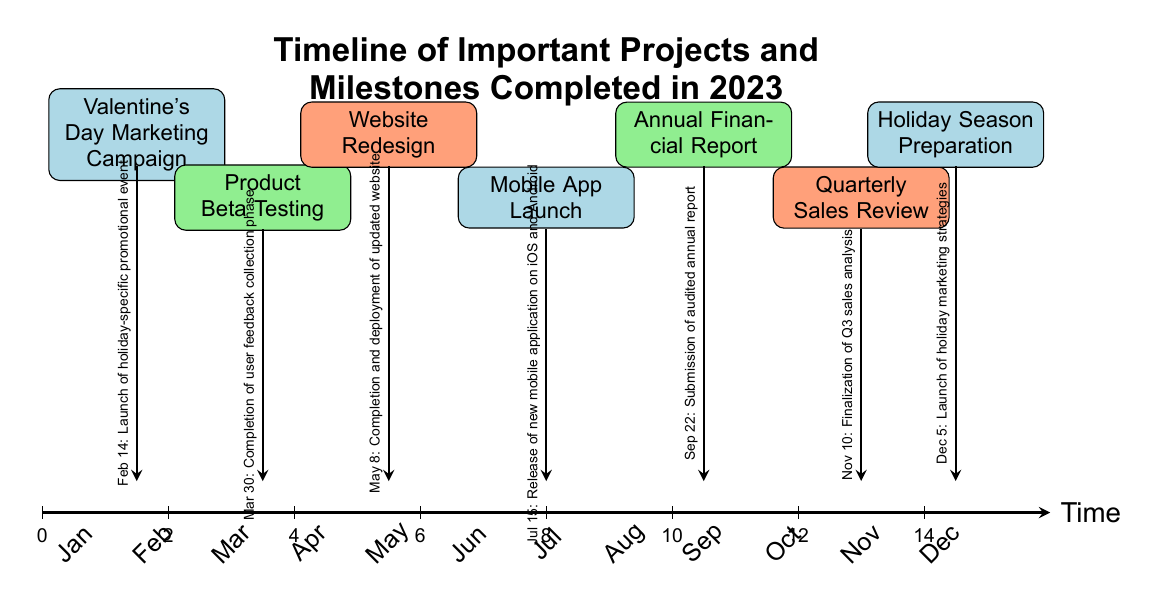What is the first project listed in the timeline? The first project listed in the timeline is the Valentine's Day Marketing Campaign, which is positioned at the coordinate (1.5, 6) on the diagram.
Answer: Valentine's Day Marketing Campaign How many projects were completed in the second quarter of 2023? The second quarter includes the months of April, May, and June. The only project completed in this timeframe is the Website Redesign in May. Thus, there is one project in Q2.
Answer: 1 What date is associated with the Mobile App Launch? The Mobile App Launch is associated with the date July 15, which is indicated next to the project node located at (8, 5) in the diagram.
Answer: July 15 Which project was completed just before the Annual Financial Report? The project completed just before the Annual Financial Report is the Mobile App Launch, as it occurs in July, while the Annual Financial Report is submitted in September.
Answer: Mobile App Launch How many months apart are the Valentine's Day Marketing Campaign and the Website Redesign? The Valentine's Day Marketing Campaign happens in February and the Website Redesign occurs in May, which is three months apart (March, April, and May).
Answer: 3 What color represents the Quarterly Sales Review in the diagram? The Quarterly Sales Review is represented by the color light orange, which is used for the project node located at (13, 5) in the timeline.
Answer: Light orange Which project is positioned at the coordinate (10.5, 6)? The project positioned at the coordinate (10.5, 6) is the Annual Financial Report, as indicated by its placement in the diagram at that specific location.
Answer: Annual Financial Report Which project was associated with a launch before the holiday season preparation? The project associated with a launch before the Holiday Season Preparation is the Mobile App Launch, as it takes place in July, while the Holiday Season Preparation occurs in December.
Answer: Mobile App Launch 